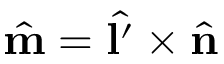Convert formula to latex. <formula><loc_0><loc_0><loc_500><loc_500>\hat { m } = \hat { l ^ { \prime } } \times \hat { n }</formula> 